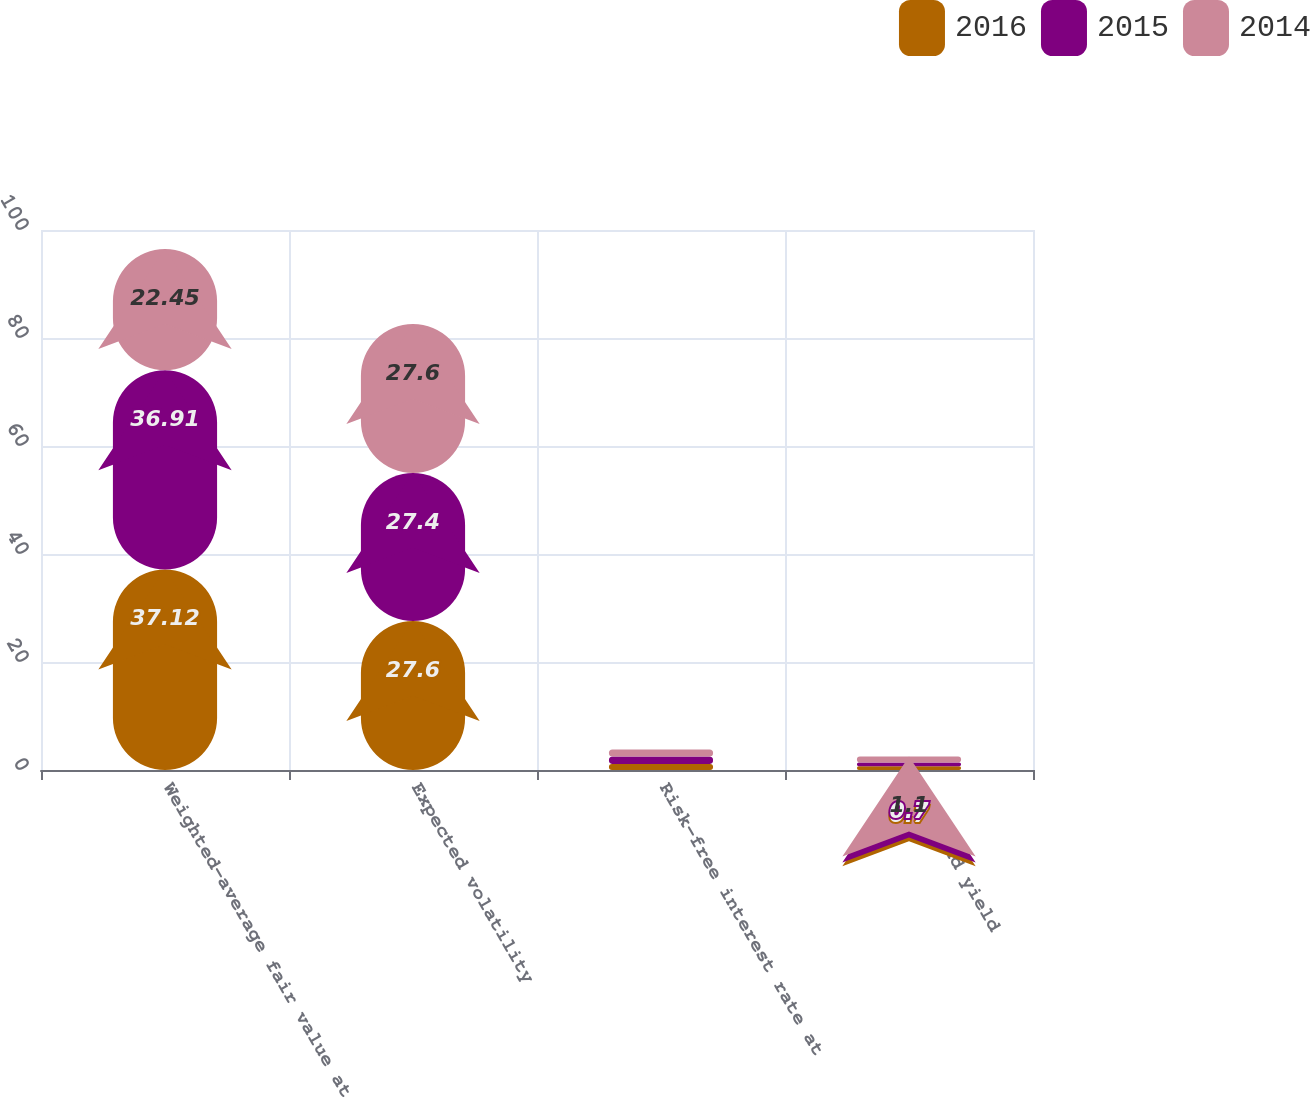Convert chart. <chart><loc_0><loc_0><loc_500><loc_500><stacked_bar_chart><ecel><fcel>Weighted-average fair value at<fcel>Expected volatility<fcel>Risk-free interest rate at<fcel>Dividend yield<nl><fcel>2016<fcel>37.12<fcel>27.6<fcel>1.1<fcel>0.7<nl><fcel>2015<fcel>36.91<fcel>27.4<fcel>1.4<fcel>0.7<nl><fcel>2014<fcel>22.45<fcel>27.6<fcel>1.3<fcel>1.1<nl></chart> 